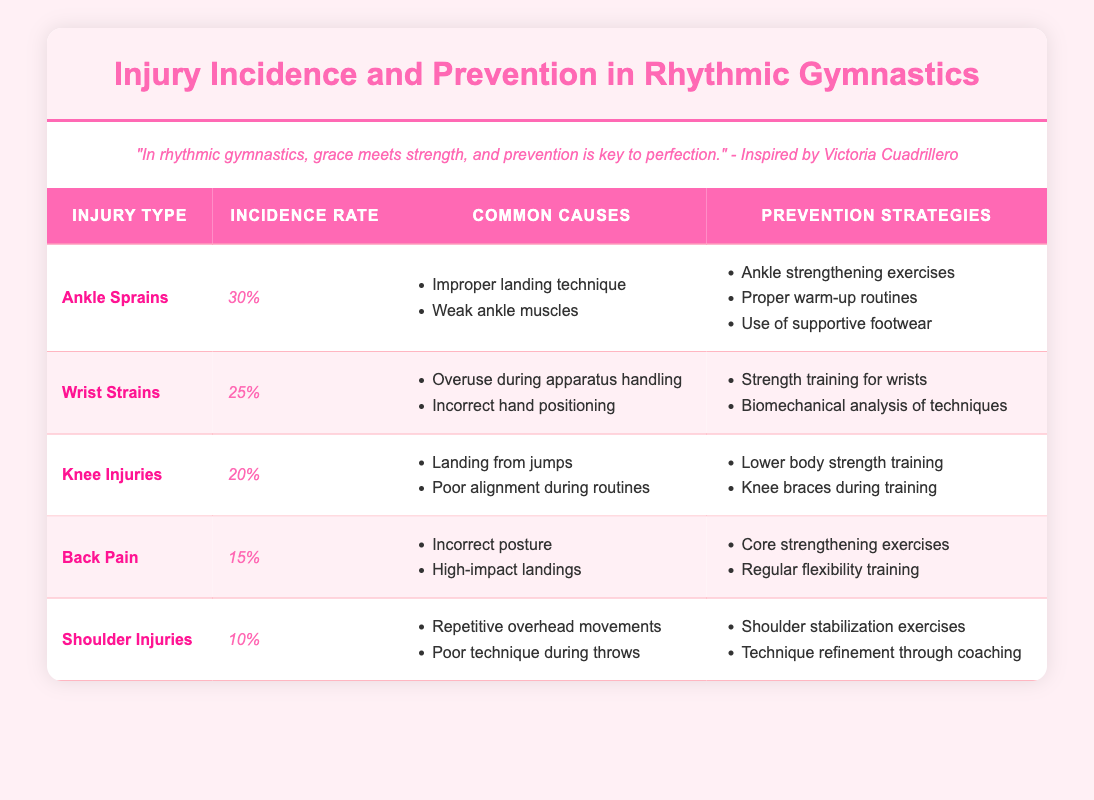What is the incidence rate of ankle sprains? The table shows that the incidence rate of ankle sprains is 30%.
Answer: 30% Which injury has the lowest incidence rate? By comparing the incidence rates from the table, shoulder injuries have the lowest rate at 10%.
Answer: 10% How many injuries have an incidence rate of 20% or higher? The injuries with an incidence rate of 20% or higher are ankle sprains (30%), wrist strains (25%), and knee injuries (20%), making it a total of 3 injuries.
Answer: 3 Is it true that wrist strains are caused by overuse during apparatus handling? The table lists overuse during apparatus handling as a common cause of wrist strains, validating the statement as true.
Answer: Yes What is the average incidence rate of all the injuries listed in the table? To find the average, we first sum the incidence rates: 30% + 25% + 20% + 15% + 10% = 100%. There are 5 injuries, so we divide 100% by 5, resulting in an average of 20%.
Answer: 20% Which injury corresponds to the prevention strategy of using knee braces during training? The prevention strategy of using knee braces is listed under knee injuries, which corresponds to the specific injury type.
Answer: Knee Injuries What are the common causes of back pain according to the table? From the table, the common causes of back pain include incorrect posture and high-impact landings.
Answer: Incorrect posture and high-impact landings Which preventive strategy is suggested for ankle sprains? The prevention strategies for ankle sprains include ankle strengthening exercises, proper warm-up routines, and use of supportive footwear as listed in the table.
Answer: Ankle strengthening exercises, proper warm-up routines, and use of supportive footwear 